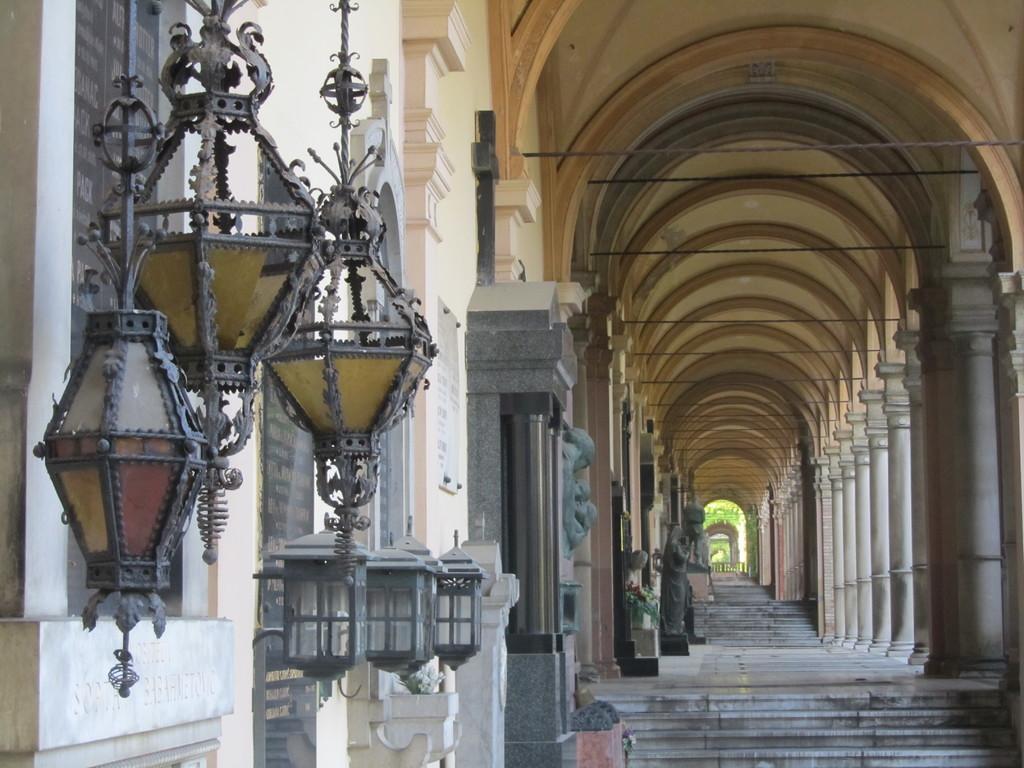In one or two sentences, can you explain what this image depicts? This image consists of a corridor. In the front, there are steps. And we can see many pillars. On the left, there are lamps hanged to the wall. 